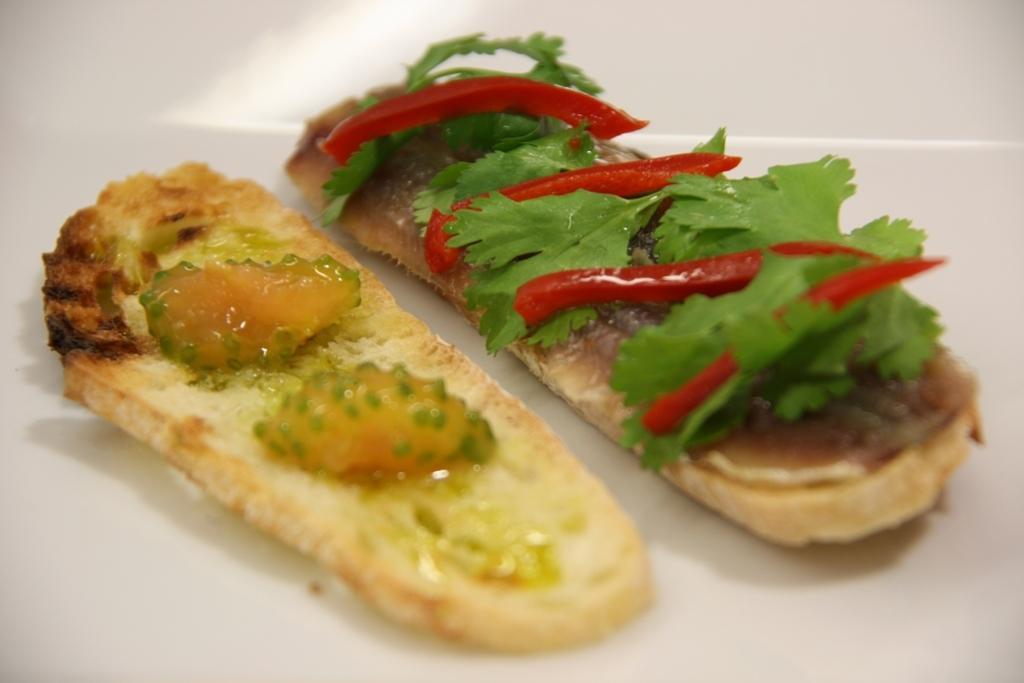Please provide a concise description of this image. In this image we can see a food item, here are the coriander leaves, here are the chillies on it. 